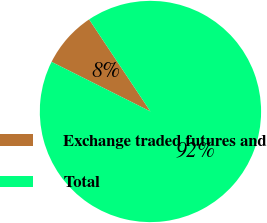<chart> <loc_0><loc_0><loc_500><loc_500><pie_chart><fcel>Exchange traded futures and<fcel>Total<nl><fcel>8.25%<fcel>91.75%<nl></chart> 